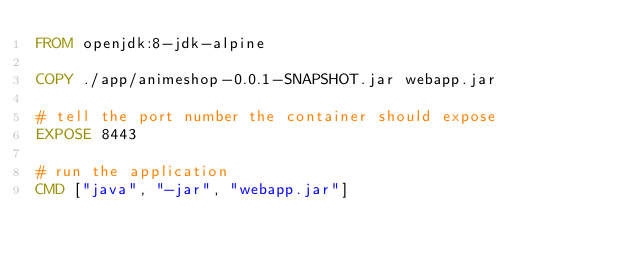Convert code to text. <code><loc_0><loc_0><loc_500><loc_500><_Dockerfile_>FROM openjdk:8-jdk-alpine

COPY ./app/animeshop-0.0.1-SNAPSHOT.jar webapp.jar

# tell the port number the container should expose
EXPOSE 8443

# run the application
CMD ["java", "-jar", "webapp.jar"]</code> 